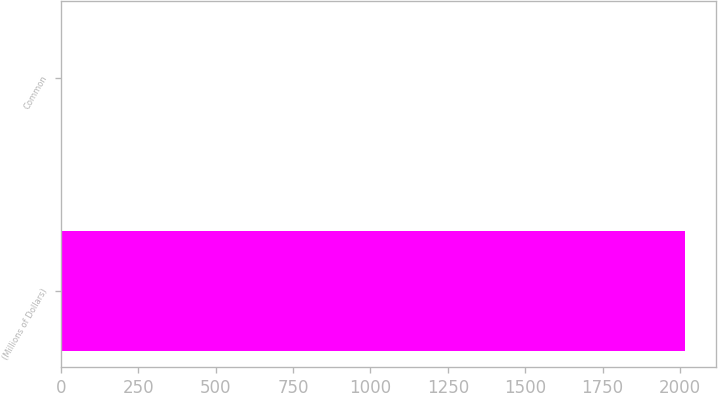Convert chart to OTSL. <chart><loc_0><loc_0><loc_500><loc_500><bar_chart><fcel>(Millions of Dollars)<fcel>Common<nl><fcel>2017<fcel>2<nl></chart> 